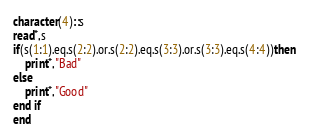<code> <loc_0><loc_0><loc_500><loc_500><_FORTRAN_>character(4)::s
read*,s
if(s(1:1).eq.s(2:2).or.s(2:2).eq.s(3:3).or.s(3:3).eq.s(4:4))then 
    print*,"Bad"
else 
    print*,"Good"
end if
end</code> 